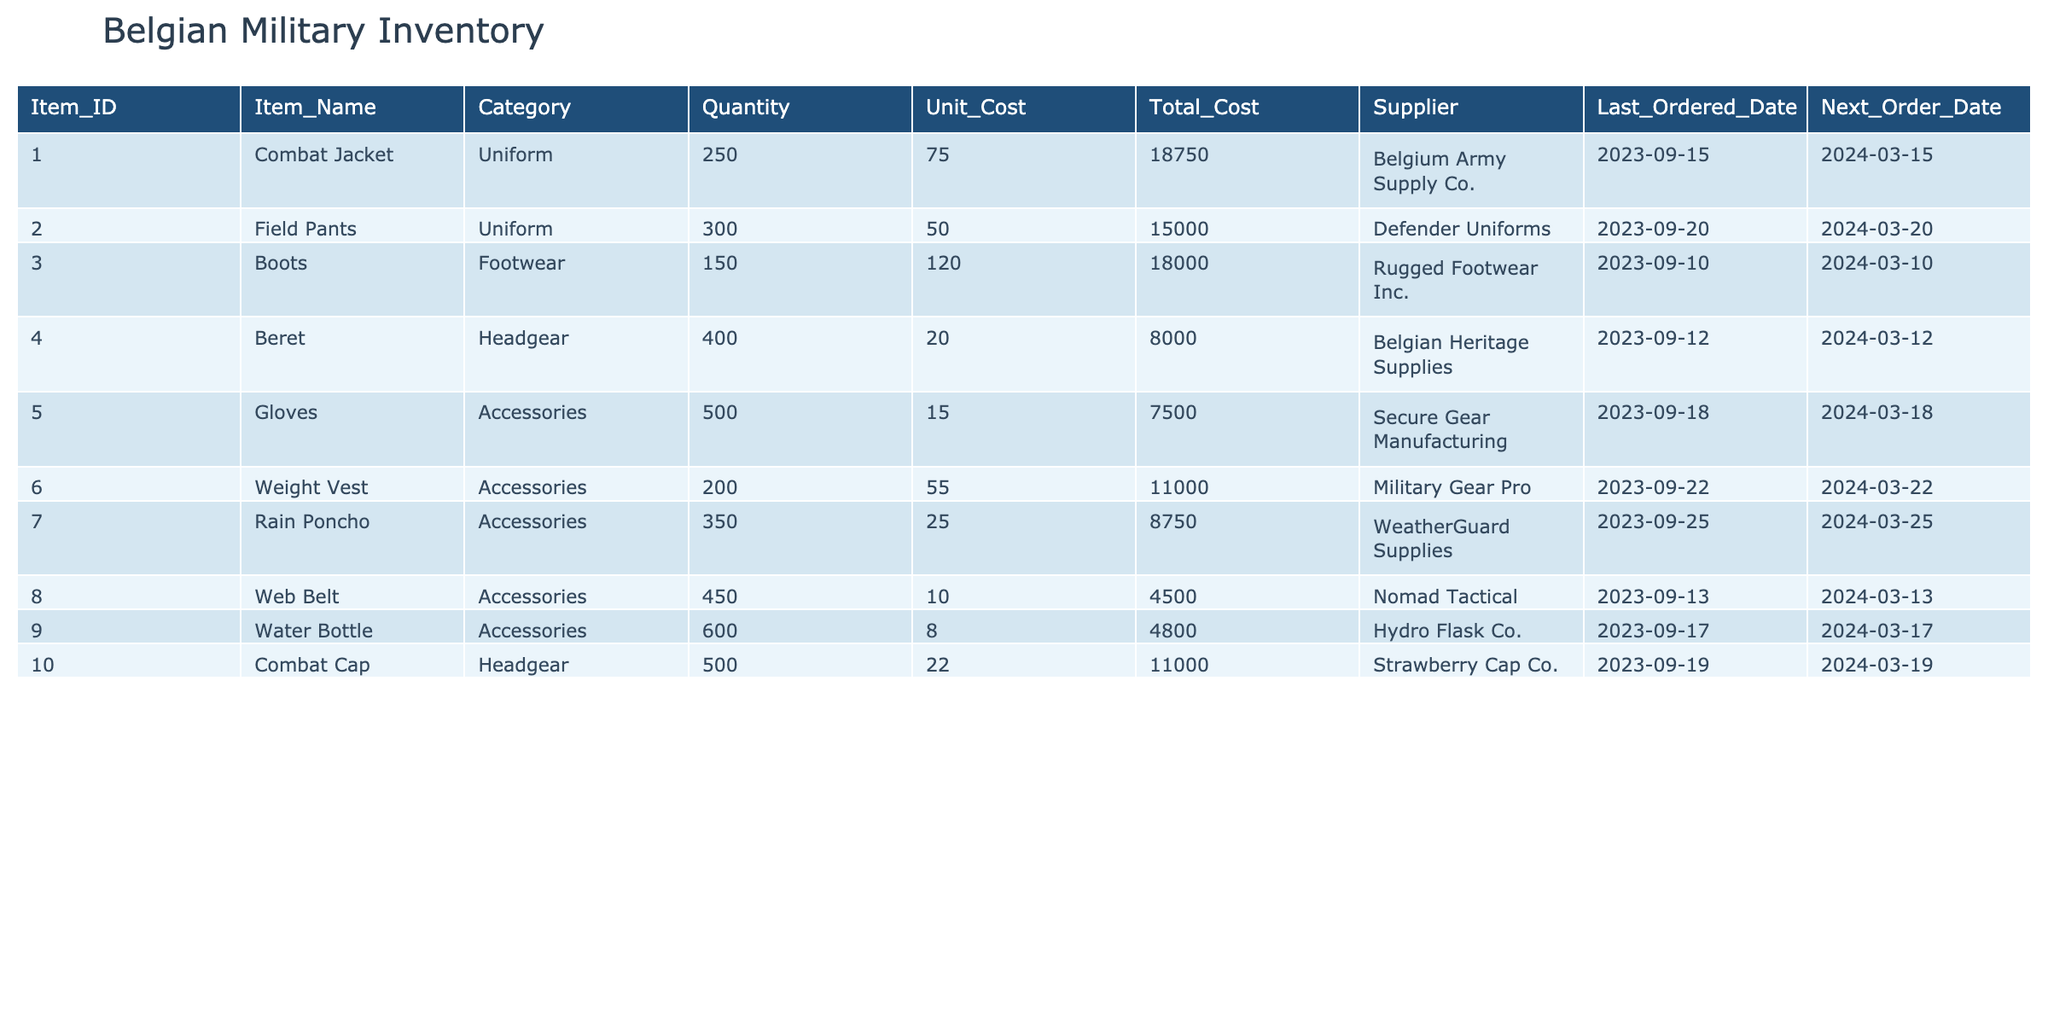What is the total quantity of Field Pants in the inventory? The quantity of Field Pants is listed directly under the Quantity column for that item, which is 300.
Answer: 300 Which item has the highest total cost? To find the item with the highest total cost, compare the Total Cost values across all items. The Combat Jacket has a Total Cost of 18,750, which is the highest among all items listed.
Answer: Combat Jacket How many units of Gloves are available compared to Web Belts? The Quantity of Gloves is 500 and the Quantity of Web Belts is 450. To compare, we can see that Gloves have 50 units more than Web Belts (500 - 450 = 50).
Answer: 50 more What is the average unit cost of Accessories in the inventory? There are three Accessories listed: Gloves (15), Weight Vest (55), and Rain Poncho (25). First, sum the unit costs: 15 + 55 + 25 = 95. Then, divide by the number of Accessories (3) to find the average: 95 / 3 = 31.67.
Answer: 31.67 Is the last ordered date for the Combat Cap later than that for the Beret? The last ordered date for the Combat Cap is 2023-09-19, while the Beret’s last ordered date is 2023-09-12. Since 2023-09-19 is later than 2023-09-12, the statement is true.
Answer: Yes Which supplier provides the highest number of items in this inventory? Observe the Supplier column: the supplier with the most distinct items listed is Belgian Heritage Supplies, which supplies 1 item (the Beret). Since all suppliers provide a single unique item, none surpasses the others.
Answer: None How many items will need to be ordered next after 2024-03-20? According to the Next Order Date column, the items Field Pants, Gloves, and Weight Vests need to be ordered after 2024-03-20. Counting these, there are 3 items.
Answer: 3 items What is the total cost of all items under the Accessories category? Sum the Total Costs for the items in the Accessories category: Gloves (7,500), Weight Vest (11,000), Rain Poncho (8,750), Web Belt (4,500), and Water Bottle (4,800). Totaling these gives 7,500 + 11,000 + 8,750 + 4,500 + 4,800 = 36,550.
Answer: 36,550 Which item has the next order date immediately after the Combat Jacket? The next order date for the Combat Jacket is 2024-03-15. Looking through the Next Order Date column, the Field Pants (2024-03-20) come next.
Answer: Field Pants 